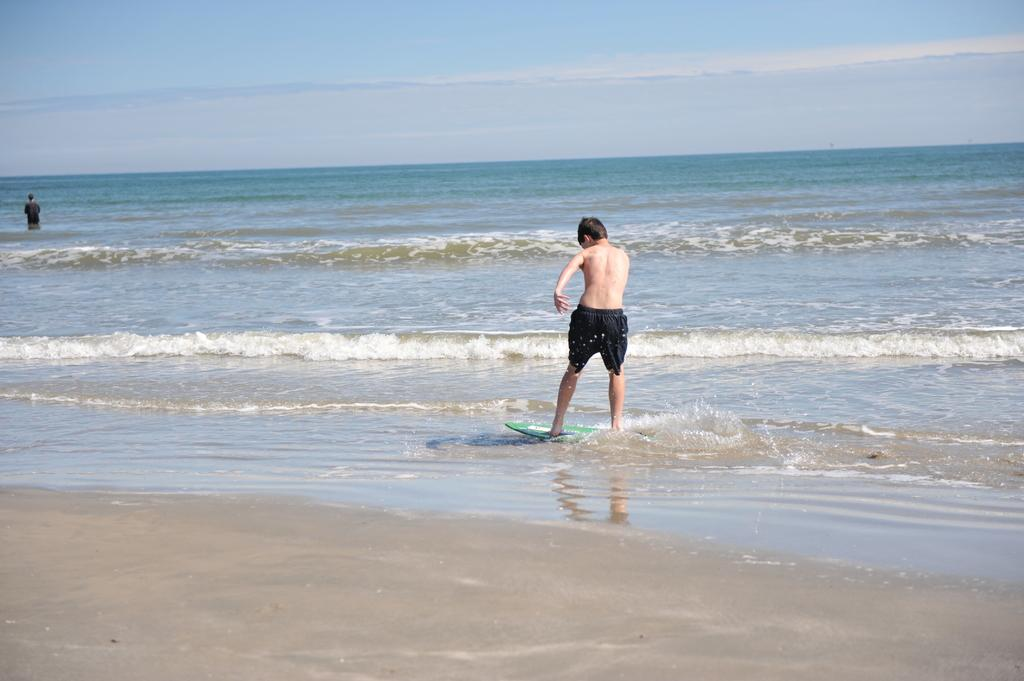How many people are in the image? There are two people standing in the image. What are the people wearing? The people are wearing clothes and shorts. What activity is depicted in the image? The image depicts a water board. What natural elements can be seen in the image? There is water and sand visible in the image. What is the color of the sky in the image? The sky is pale blue in the image. What type of cat can be seen singing a song in the image? There is no cat or song present in the image; it features two people standing near a water board. What kind of lumber is being used to construct the water board in the image? There is no lumber visible in the image; the water board appears to be made of a different material. 